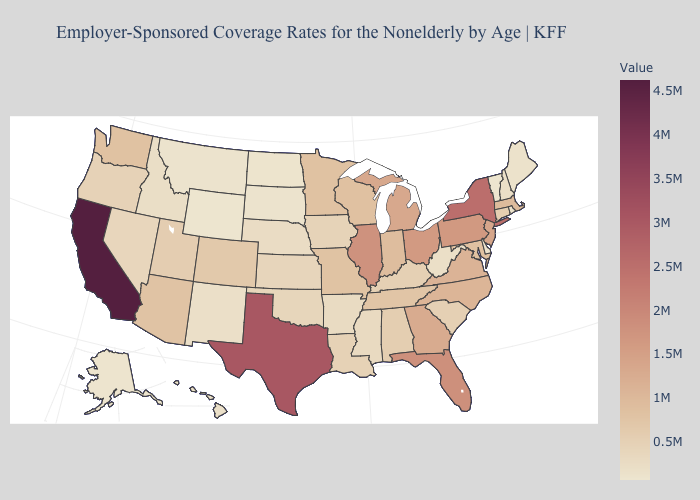Is the legend a continuous bar?
Concise answer only. Yes. Does Kentucky have the lowest value in the USA?
Be succinct. No. Among the states that border Vermont , does Massachusetts have the highest value?
Concise answer only. No. Does New York have the highest value in the USA?
Short answer required. No. Does Nebraska have a higher value than Massachusetts?
Write a very short answer. No. 